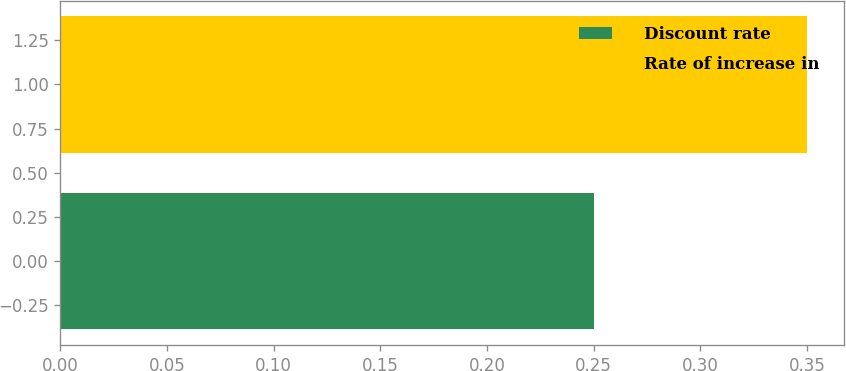Convert chart to OTSL. <chart><loc_0><loc_0><loc_500><loc_500><bar_chart><fcel>Discount rate<fcel>Rate of increase in<nl><fcel>0.25<fcel>0.35<nl></chart> 